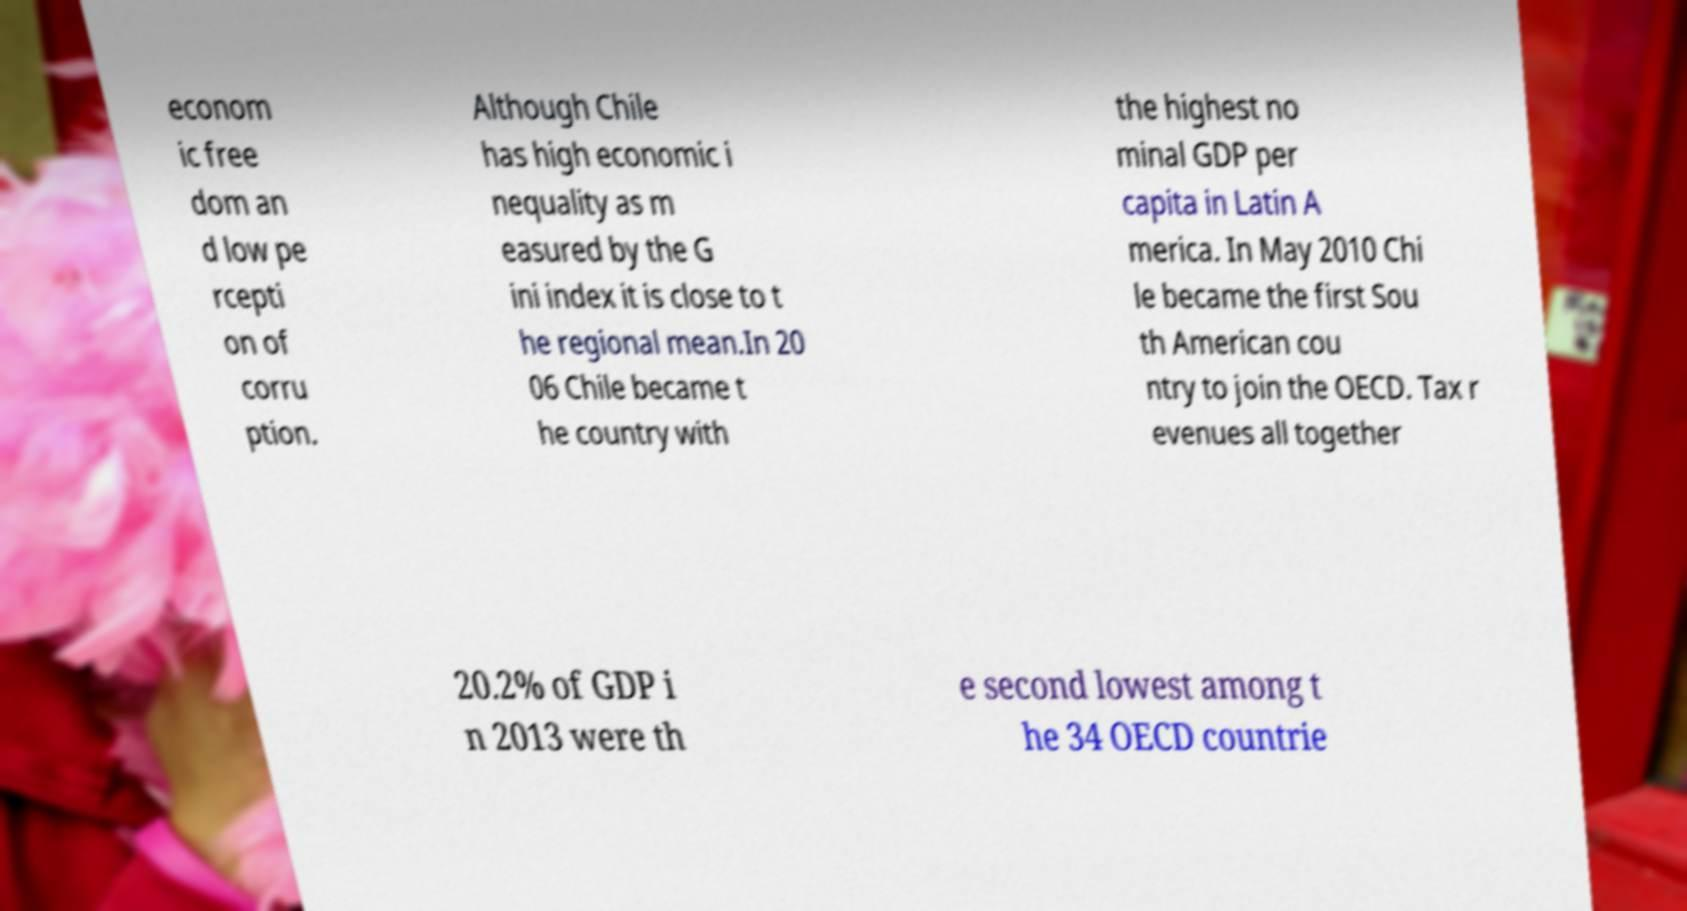Please read and relay the text visible in this image. What does it say? econom ic free dom an d low pe rcepti on of corru ption. Although Chile has high economic i nequality as m easured by the G ini index it is close to t he regional mean.In 20 06 Chile became t he country with the highest no minal GDP per capita in Latin A merica. In May 2010 Chi le became the first Sou th American cou ntry to join the OECD. Tax r evenues all together 20.2% of GDP i n 2013 were th e second lowest among t he 34 OECD countrie 